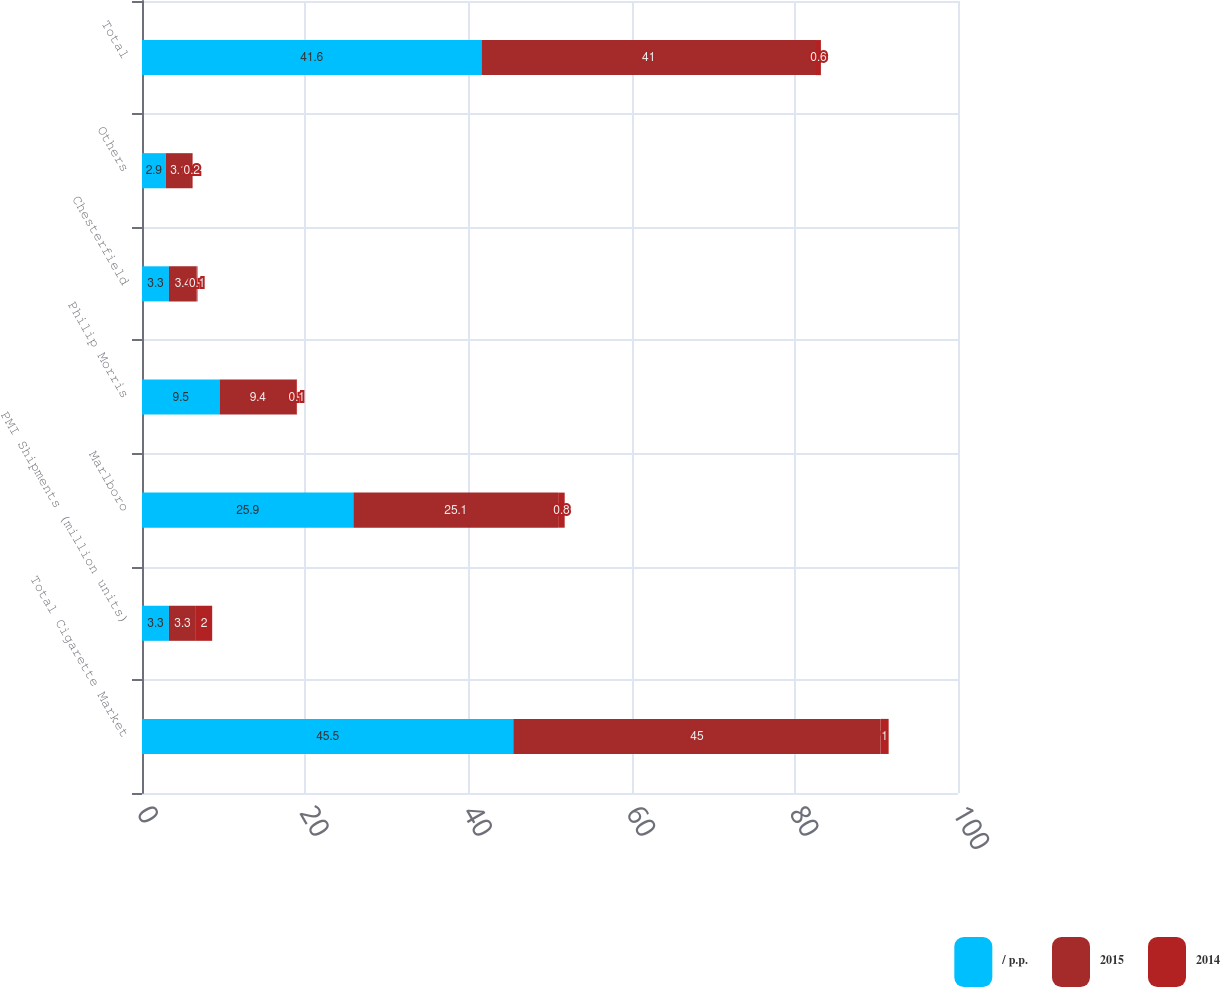Convert chart to OTSL. <chart><loc_0><loc_0><loc_500><loc_500><stacked_bar_chart><ecel><fcel>Total Cigarette Market<fcel>PMI Shipments (million units)<fcel>Marlboro<fcel>Philip Morris<fcel>Chesterfield<fcel>Others<fcel>Total<nl><fcel>/ p.p.<fcel>45.5<fcel>3.3<fcel>25.9<fcel>9.5<fcel>3.3<fcel>2.9<fcel>41.6<nl><fcel>2015<fcel>45<fcel>3.3<fcel>25.1<fcel>9.4<fcel>3.4<fcel>3.1<fcel>41<nl><fcel>2014<fcel>1<fcel>2<fcel>0.8<fcel>0.1<fcel>0.1<fcel>0.2<fcel>0.6<nl></chart> 